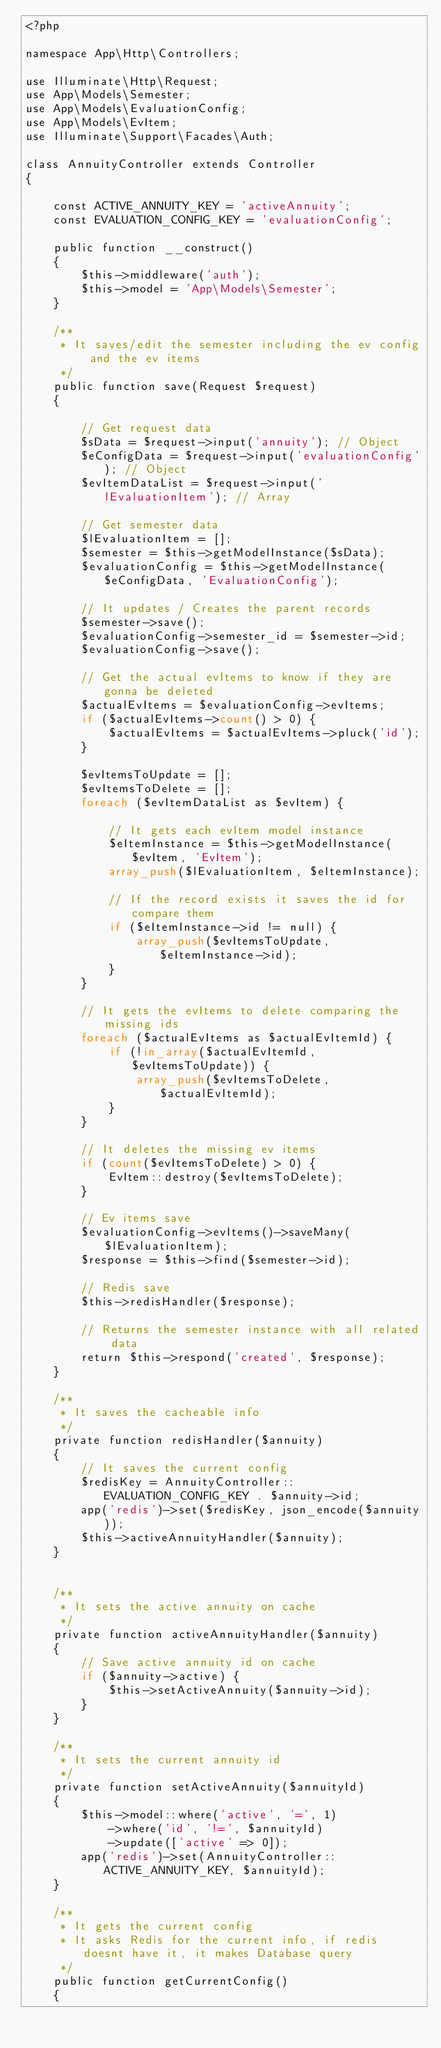<code> <loc_0><loc_0><loc_500><loc_500><_PHP_><?php

namespace App\Http\Controllers;

use Illuminate\Http\Request;
use App\Models\Semester;
use App\Models\EvaluationConfig;
use App\Models\EvItem;
use Illuminate\Support\Facades\Auth;

class AnnuityController extends Controller
{

    const ACTIVE_ANNUITY_KEY = 'activeAnnuity';
    const EVALUATION_CONFIG_KEY = 'evaluationConfig';

    public function __construct()
    {
        $this->middleware('auth');
        $this->model = 'App\Models\Semester';
    }

    /**
     * It saves/edit the semester including the ev config and the ev items
     */
    public function save(Request $request)
    {

        // Get request data
        $sData = $request->input('annuity'); // Object
        $eConfigData = $request->input('evaluationConfig'); // Object
        $evItemDataList = $request->input('lEvaluationItem'); // Array

        // Get semester data 
        $lEvaluationItem = [];
        $semester = $this->getModelInstance($sData);
        $evaluationConfig = $this->getModelInstance($eConfigData, 'EvaluationConfig');

        // It updates / Creates the parent records
        $semester->save();
        $evaluationConfig->semester_id = $semester->id;
        $evaluationConfig->save();

        // Get the actual evItems to know if they are gonna be deleted
        $actualEvItems = $evaluationConfig->evItems;
        if ($actualEvItems->count() > 0) {
            $actualEvItems = $actualEvItems->pluck('id');
        }

        $evItemsToUpdate = [];
        $evItemsToDelete = [];
        foreach ($evItemDataList as $evItem) {

            // It gets each evItem model instance
            $eItemInstance = $this->getModelInstance($evItem, 'EvItem');
            array_push($lEvaluationItem, $eItemInstance);

            // If the record exists it saves the id for compare them 
            if ($eItemInstance->id != null) {
                array_push($evItemsToUpdate, $eItemInstance->id);
            }
        }

        // It gets the evItems to delete comparing the missing ids
        foreach ($actualEvItems as $actualEvItemId) {
            if (!in_array($actualEvItemId, $evItemsToUpdate)) {
                array_push($evItemsToDelete, $actualEvItemId);
            }
        }

        // It deletes the missing ev items
        if (count($evItemsToDelete) > 0) {
            EvItem::destroy($evItemsToDelete);
        }

        // Ev items save
        $evaluationConfig->evItems()->saveMany($lEvaluationItem);
        $response = $this->find($semester->id);

        // Redis save
        $this->redisHandler($response);

        // Returns the semester instance with all related data
        return $this->respond('created', $response);
    }

    /**
     * It saves the cacheable info
     */
    private function redisHandler($annuity)
    {
        // It saves the current config
        $redisKey = AnnuityController::EVALUATION_CONFIG_KEY . $annuity->id;
        app('redis')->set($redisKey, json_encode($annuity));
        $this->activeAnnuityHandler($annuity);
    }


    /**
     * It sets the active annuity on cache
     */
    private function activeAnnuityHandler($annuity)
    {
        // Save active annuity id on cache
        if ($annuity->active) {
            $this->setActiveAnnuity($annuity->id);
        }
    }

    /**
     * It sets the current annuity id 
     */
    private function setActiveAnnuity($annuityId)
    {
        $this->model::where('active', '=', 1)
            ->where('id', '!=', $annuityId)
            ->update(['active' => 0]);
        app('redis')->set(AnnuityController::ACTIVE_ANNUITY_KEY, $annuityId);
    }

    /**
     * It gets the current config
     * It asks Redis for the current info, if redis doesnt have it, it makes Database query
     */
    public function getCurrentConfig()
    {</code> 